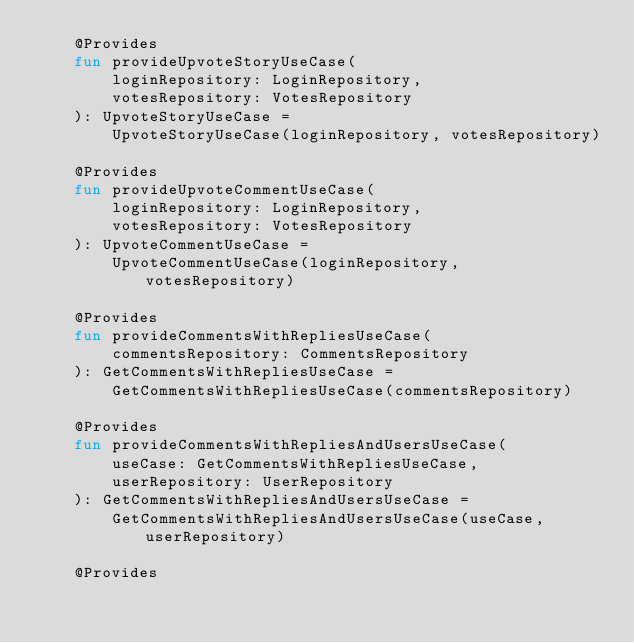<code> <loc_0><loc_0><loc_500><loc_500><_Kotlin_>    @Provides
    fun provideUpvoteStoryUseCase(
        loginRepository: LoginRepository,
        votesRepository: VotesRepository
    ): UpvoteStoryUseCase =
        UpvoteStoryUseCase(loginRepository, votesRepository)

    @Provides
    fun provideUpvoteCommentUseCase(
        loginRepository: LoginRepository,
        votesRepository: VotesRepository
    ): UpvoteCommentUseCase =
        UpvoteCommentUseCase(loginRepository, votesRepository)

    @Provides
    fun provideCommentsWithRepliesUseCase(
        commentsRepository: CommentsRepository
    ): GetCommentsWithRepliesUseCase =
        GetCommentsWithRepliesUseCase(commentsRepository)

    @Provides
    fun provideCommentsWithRepliesAndUsersUseCase(
        useCase: GetCommentsWithRepliesUseCase,
        userRepository: UserRepository
    ): GetCommentsWithRepliesAndUsersUseCase =
        GetCommentsWithRepliesAndUsersUseCase(useCase, userRepository)

    @Provides</code> 